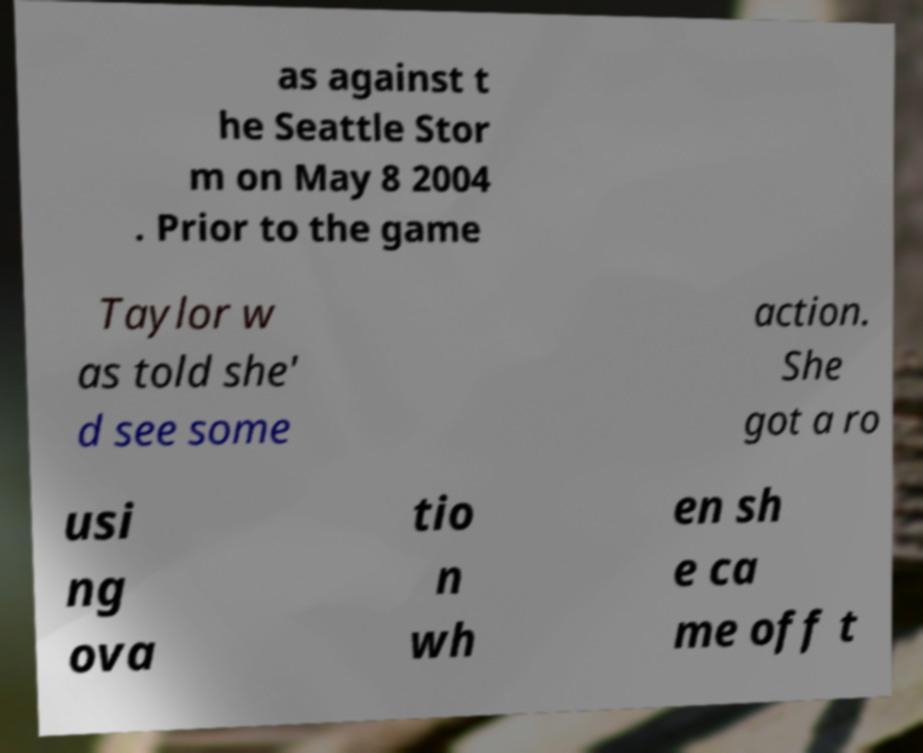I need the written content from this picture converted into text. Can you do that? as against t he Seattle Stor m on May 8 2004 . Prior to the game Taylor w as told she' d see some action. She got a ro usi ng ova tio n wh en sh e ca me off t 